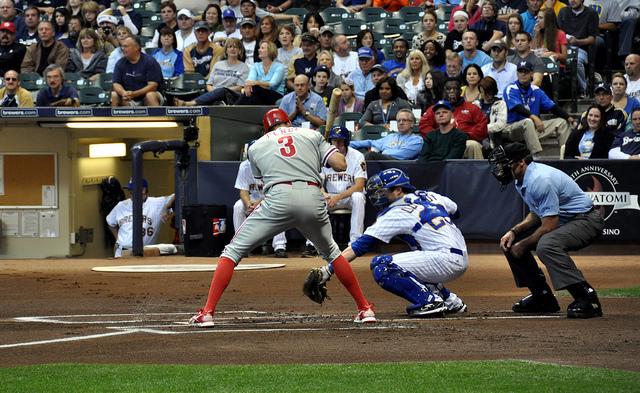What is the man in black doing?
Quick response, please. Watching. What number is the ump?
Give a very brief answer. 0. What game is being played?
Quick response, please. Baseball. What color socks is number 3 wearing?
Concise answer only. Red. Where are the spectators?
Concise answer only. In stands. 